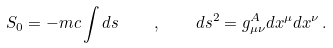<formula> <loc_0><loc_0><loc_500><loc_500>S _ { 0 } = - m c \int d s \quad , \quad d s ^ { 2 } = g ^ { A } _ { \mu \nu } d x ^ { \mu } d x ^ { \nu } \, .</formula> 